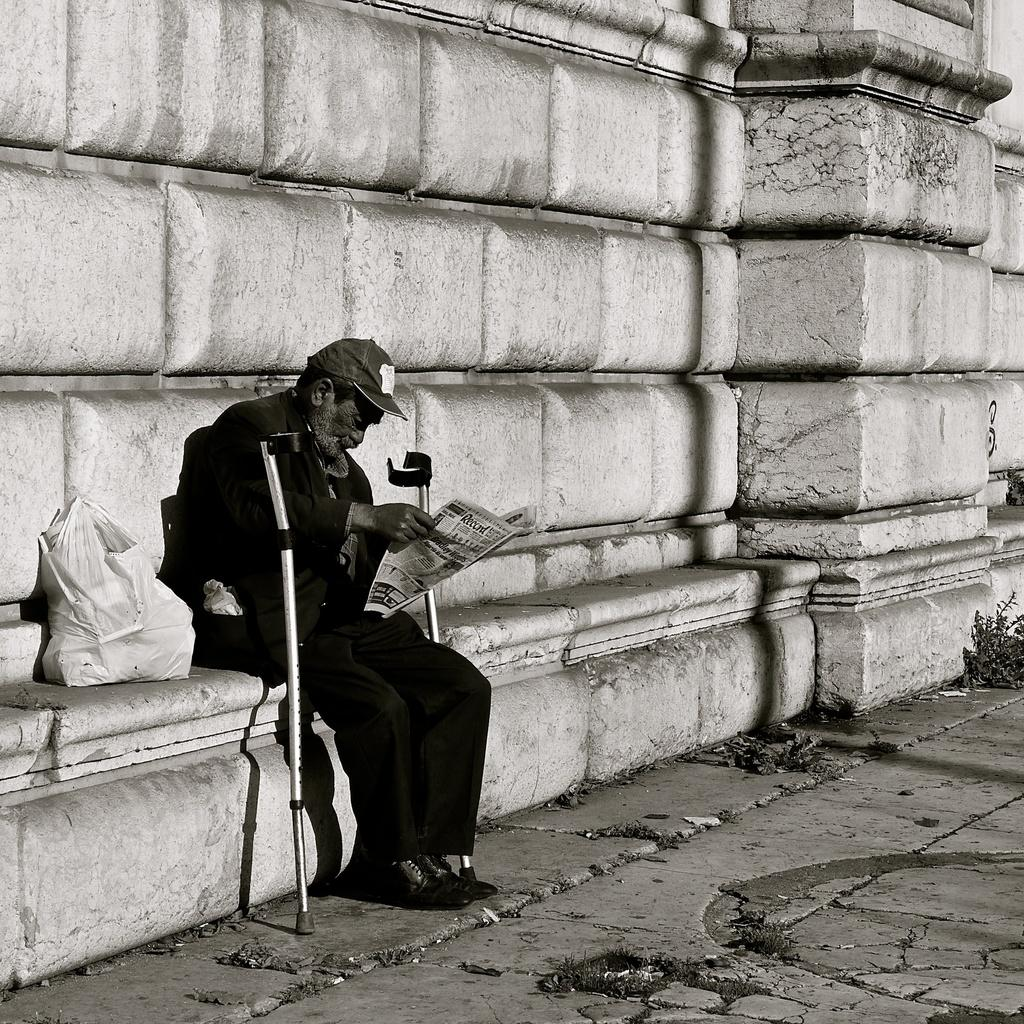What is the color scheme of the image? The image is black and white. What is the person in the image doing? The person is sitting and reading a newspaper. What can be seen in the background of the image? There is a wall in the background of the image. How many houses are visible in the image? There are no houses visible in the image; it only features a person sitting and reading a newspaper with a wall in the background. 